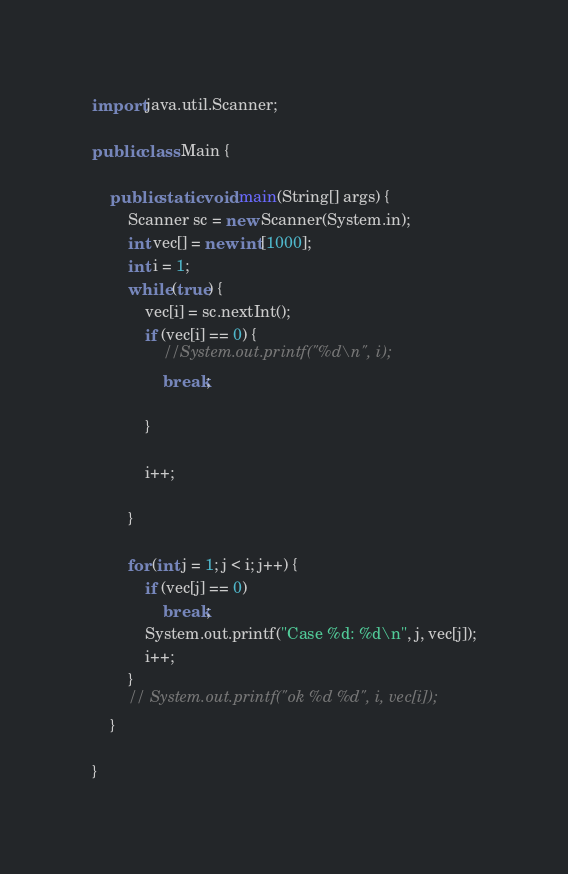<code> <loc_0><loc_0><loc_500><loc_500><_Java_>import java.util.Scanner;

public class Main {

	public static void main(String[] args) {
		Scanner sc = new Scanner(System.in);
		int vec[] = new int[1000];
		int i = 1;
		while (true) {
			vec[i] = sc.nextInt();
			if (vec[i] == 0) {
				//System.out.printf("%d\n", i);
				break;

			}

			i++;

		}

		for (int j = 1; j < i; j++) {
			if (vec[j] == 0)
				break;
			System.out.printf("Case %d: %d\n", j, vec[j]);
			i++;
		}
		// System.out.printf("ok %d %d", i, vec[i]);
	}

}</code> 